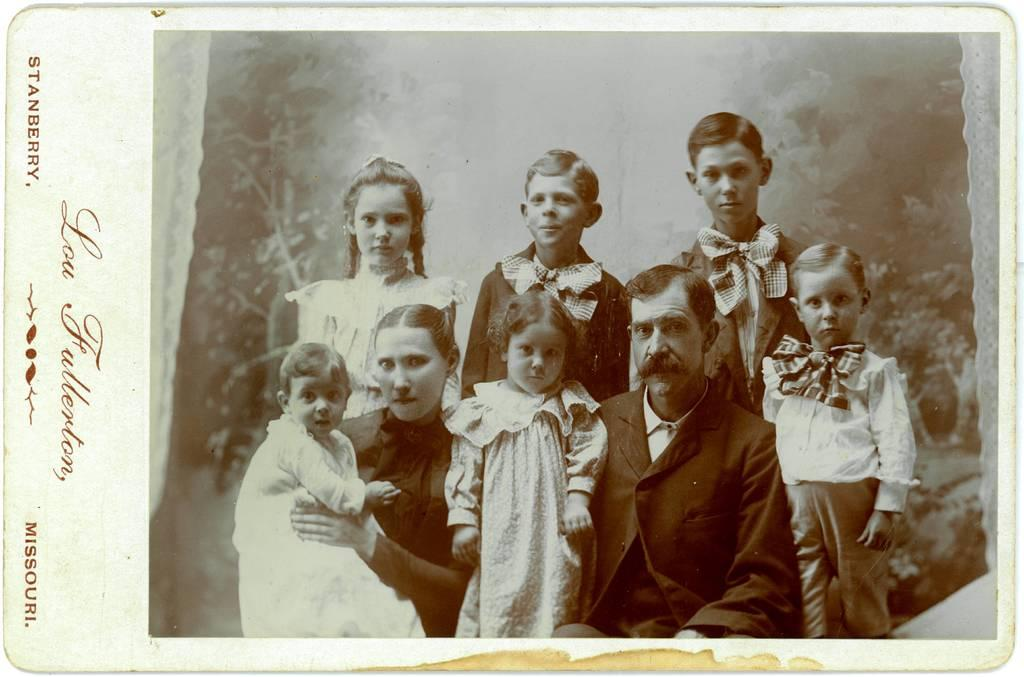What is the main object in the image? There is a card in the image. What can be found on the card? The card contains a picture and some text. Who is observing the card in the image? There is a group of people watching in the image. What can be seen in the background of the image? There are plants visible in the background of the image. What type of lamp is being used to illuminate the wood in the image? There is no lamp or wood present in the image; it features a card with a picture and text, a group of people watching, and plants in the background. 